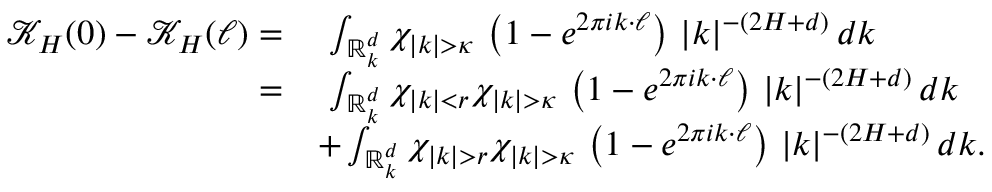<formula> <loc_0><loc_0><loc_500><loc_500>\begin{array} { r l } { \mathcal { K } _ { H } ( 0 ) - \mathcal { K } _ { H } ( \ell ) = } & { \ \int _ { \mathbb { R } _ { k } ^ { d } } \chi _ { | k | > \kappa } \, \left ( 1 - e ^ { 2 \pi i k \cdot \ell } \right ) \, | k | ^ { - ( 2 H + d ) } \, d k } \\ { = } & { \ \int _ { \mathbb { R } _ { k } ^ { d } } \chi _ { | k | < r } \chi _ { | k | > \kappa } \, \left ( 1 - e ^ { 2 \pi i k \cdot \ell } \right ) \, | k | ^ { - ( 2 H + d ) } \, d k } \\ & { + \int _ { \mathbb { R } _ { k } ^ { d } } \chi _ { | k | > r } \chi _ { | k | > \kappa } \, \left ( 1 - e ^ { 2 \pi i k \cdot \ell } \right ) \, | k | ^ { - ( 2 H + d ) } \, d k . } \end{array}</formula> 